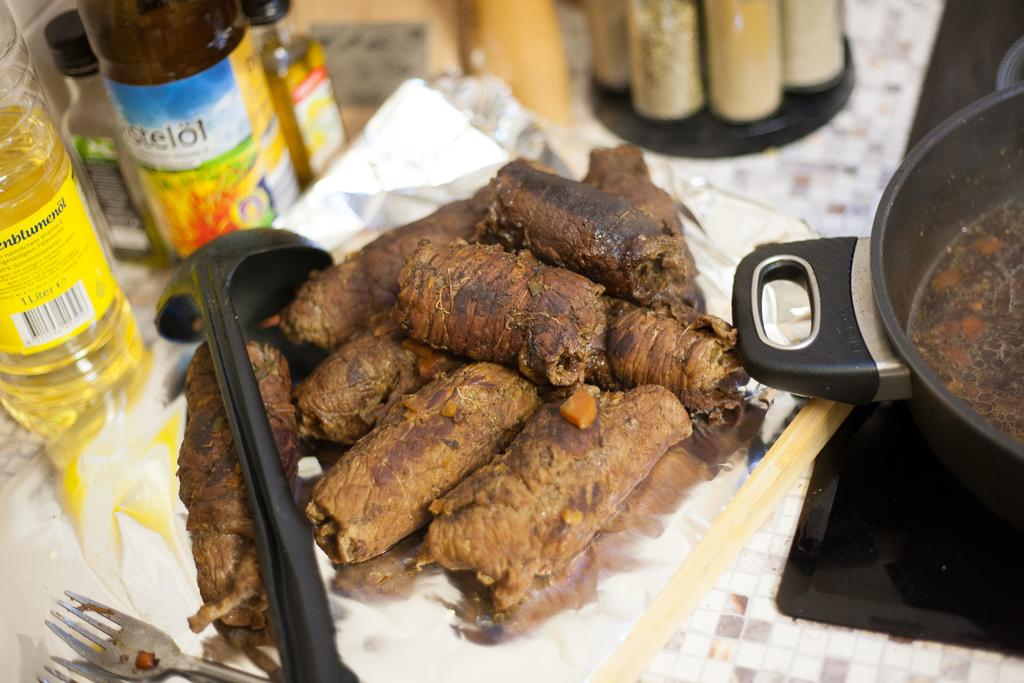What is the main subject of the image? There is a food item in the image. Can you describe the other objects present in the image? There are other objects on a surface in the image. What street is the scarecrow standing on in the image? There is no scarecrow or street present in the image. 